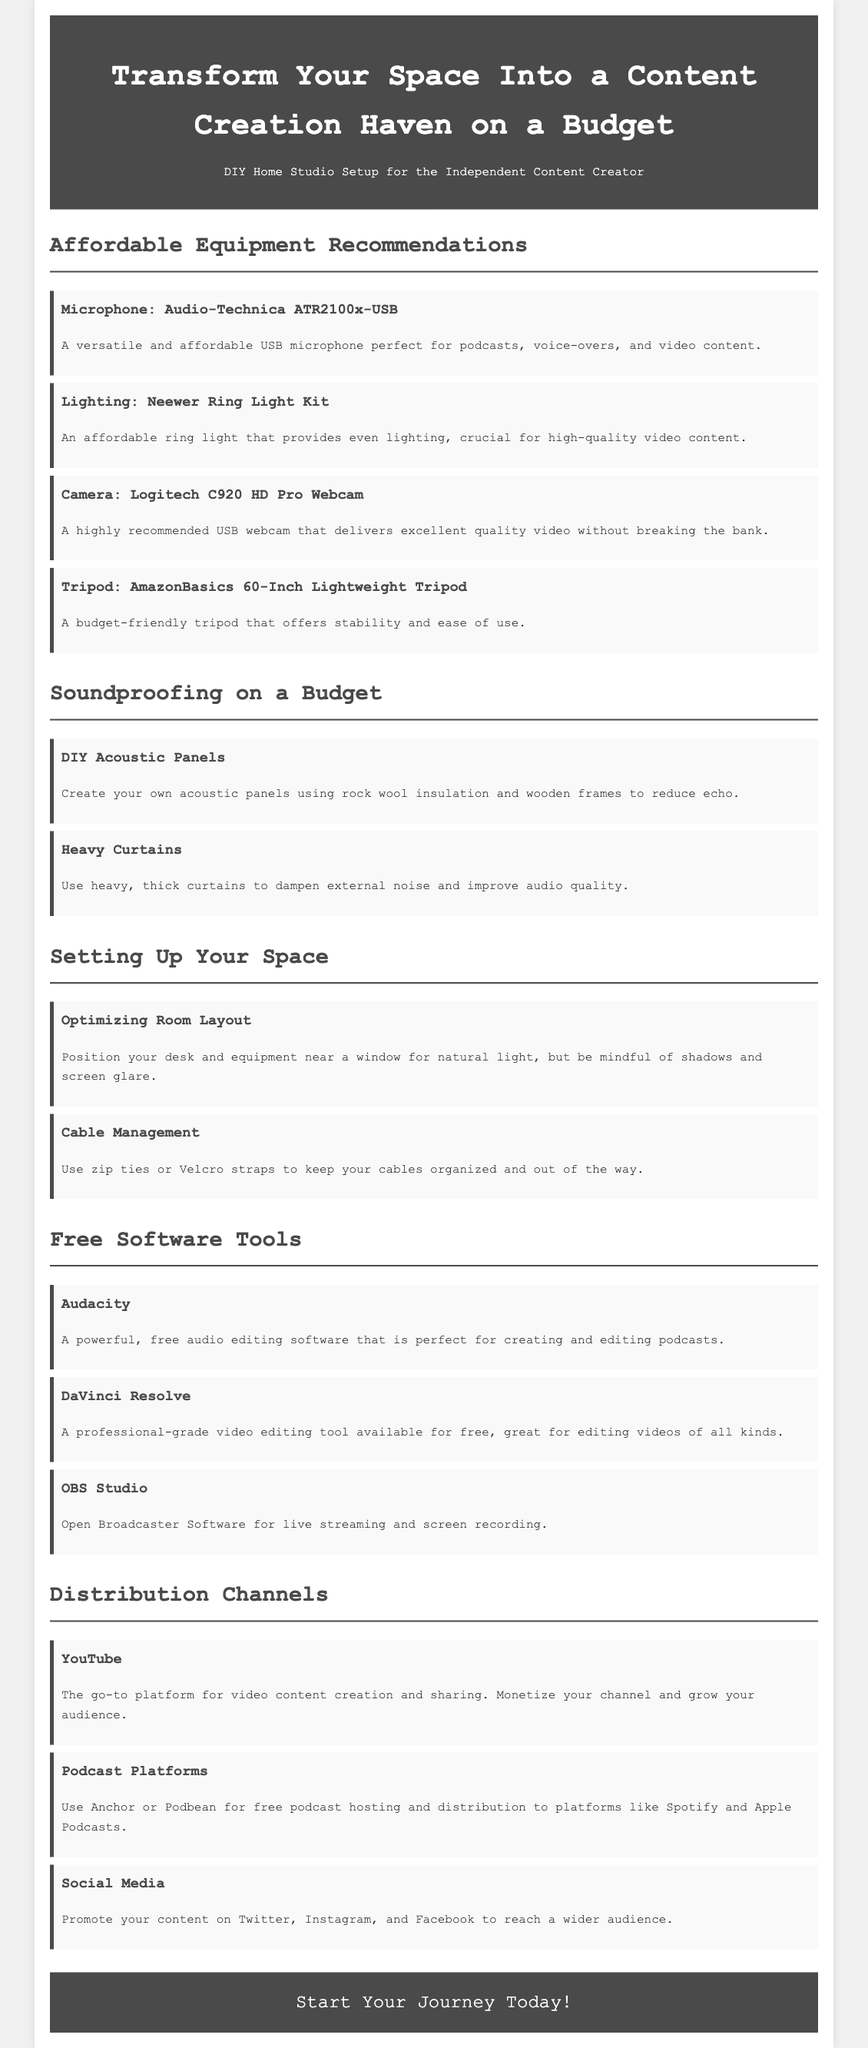what is the title of the document? The title is prominently displayed in the header of the document, which introduces the main topic.
Answer: Transform Your Space Into a Content Creation Haven on a Budget which microphone is recommended? The document lists specific equipment recommendations for content creation, including a microphone.
Answer: Audio-Technica ATR2100x-USB what type of lighting is suggested? The section on affordable equipment provides specific products, including the type of lighting recommended for video content.
Answer: Neewer Ring Light Kit how many pieces of free software tools are listed? The document details free software tools available for content creators, which include a list of three specific tools.
Answer: 3 what is the main purpose of DIY acoustic panels? This relates to the soundproofing section, discussing why one might create acoustic panels.
Answer: Reduce echo which platform is mentioned for video content sharing? The distribution channels section lists different platforms, specifically identifying one for video.
Answer: YouTube what should be used for cable management? This question pertains to the organization of space, providing a simple solution offered in the document.
Answer: Zip ties or Velcro straps what kind of curtains are recommended for soundproofing? The document suggests specific items for improving audio quality, including curtain type.
Answer: Heavy curtains 